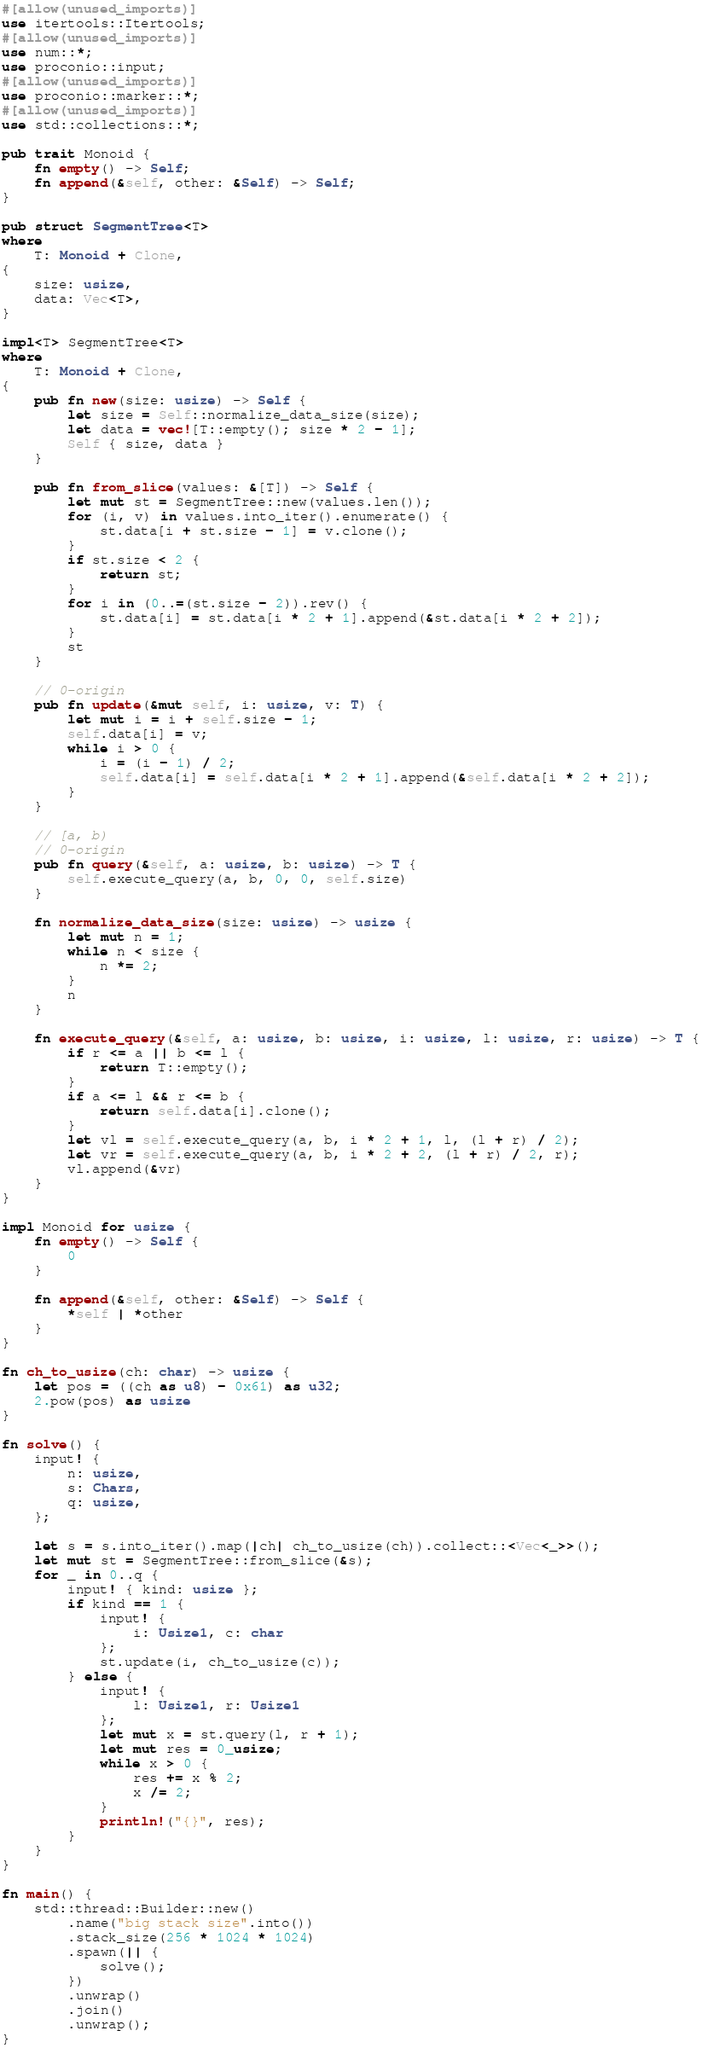Convert code to text. <code><loc_0><loc_0><loc_500><loc_500><_Rust_>#[allow(unused_imports)]
use itertools::Itertools;
#[allow(unused_imports)]
use num::*;
use proconio::input;
#[allow(unused_imports)]
use proconio::marker::*;
#[allow(unused_imports)]
use std::collections::*;

pub trait Monoid {
    fn empty() -> Self;
    fn append(&self, other: &Self) -> Self;
}

pub struct SegmentTree<T>
where
    T: Monoid + Clone,
{
    size: usize,
    data: Vec<T>,
}

impl<T> SegmentTree<T>
where
    T: Monoid + Clone,
{
    pub fn new(size: usize) -> Self {
        let size = Self::normalize_data_size(size);
        let data = vec![T::empty(); size * 2 - 1];
        Self { size, data }
    }

    pub fn from_slice(values: &[T]) -> Self {
        let mut st = SegmentTree::new(values.len());
        for (i, v) in values.into_iter().enumerate() {
            st.data[i + st.size - 1] = v.clone();
        }
        if st.size < 2 {
            return st;
        }
        for i in (0..=(st.size - 2)).rev() {
            st.data[i] = st.data[i * 2 + 1].append(&st.data[i * 2 + 2]);
        }
        st
    }

    // 0-origin
    pub fn update(&mut self, i: usize, v: T) {
        let mut i = i + self.size - 1;
        self.data[i] = v;
        while i > 0 {
            i = (i - 1) / 2;
            self.data[i] = self.data[i * 2 + 1].append(&self.data[i * 2 + 2]);
        }
    }

    // [a, b)
    // 0-origin
    pub fn query(&self, a: usize, b: usize) -> T {
        self.execute_query(a, b, 0, 0, self.size)
    }

    fn normalize_data_size(size: usize) -> usize {
        let mut n = 1;
        while n < size {
            n *= 2;
        }
        n
    }

    fn execute_query(&self, a: usize, b: usize, i: usize, l: usize, r: usize) -> T {
        if r <= a || b <= l {
            return T::empty();
        }
        if a <= l && r <= b {
            return self.data[i].clone();
        }
        let vl = self.execute_query(a, b, i * 2 + 1, l, (l + r) / 2);
        let vr = self.execute_query(a, b, i * 2 + 2, (l + r) / 2, r);
        vl.append(&vr)
    }
}

impl Monoid for usize {
    fn empty() -> Self {
        0
    }

    fn append(&self, other: &Self) -> Self {
        *self | *other
    }
}

fn ch_to_usize(ch: char) -> usize {
    let pos = ((ch as u8) - 0x61) as u32;
    2.pow(pos) as usize
}

fn solve() {
    input! {
        n: usize,
        s: Chars,
        q: usize,
    };

    let s = s.into_iter().map(|ch| ch_to_usize(ch)).collect::<Vec<_>>();
    let mut st = SegmentTree::from_slice(&s);
    for _ in 0..q {
        input! { kind: usize };
        if kind == 1 {
            input! {
                i: Usize1, c: char
            };
            st.update(i, ch_to_usize(c));
        } else {
            input! {
                l: Usize1, r: Usize1
            };
            let mut x = st.query(l, r + 1);
            let mut res = 0_usize;
            while x > 0 {
                res += x % 2;
                x /= 2;
            }
            println!("{}", res);
        }
    }
}

fn main() {
    std::thread::Builder::new()
        .name("big stack size".into())
        .stack_size(256 * 1024 * 1024)
        .spawn(|| {
            solve();
        })
        .unwrap()
        .join()
        .unwrap();
}
</code> 